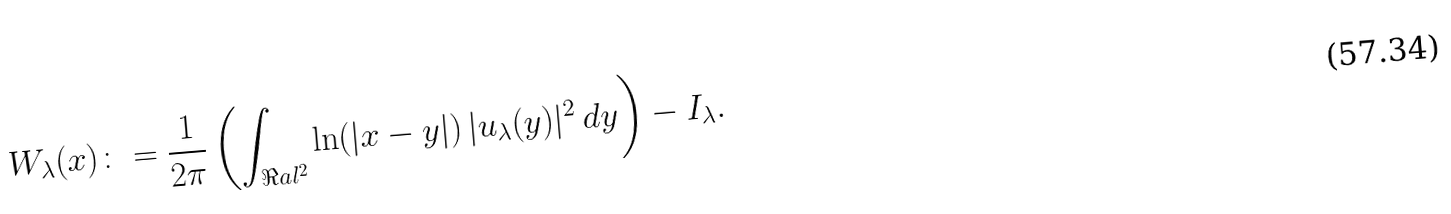Convert formula to latex. <formula><loc_0><loc_0><loc_500><loc_500>W _ { \lambda } ( x ) \colon = \frac { 1 } { 2 \pi } \left ( \int _ { \Re a l ^ { 2 } } \ln ( | x - y | ) \, | u _ { \lambda } ( y ) | ^ { 2 } \, d y \right ) - I _ { \lambda } .</formula> 